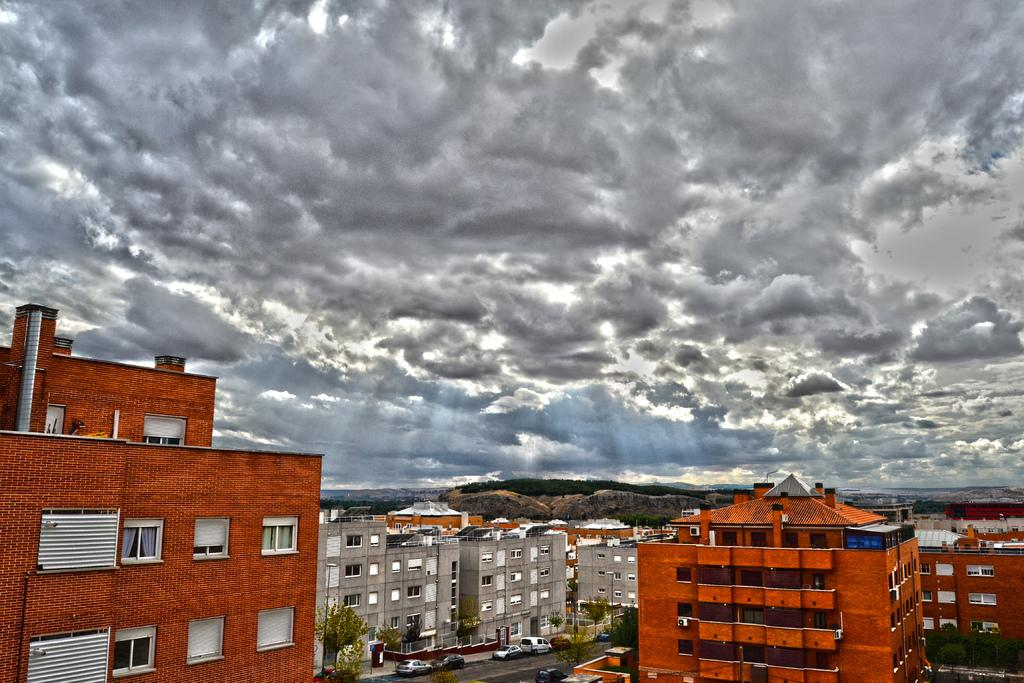What type of building can be seen on the left side of the image? There is a building in orange color on the left side of the image. What can be seen in the middle of the image? There are cars parked on the road in the middle of the image. What is the condition of the sky in the image? The sky is cloudy in the image. Can you tell me how many actors are visible in the image? There are no actors present in the image; it features a building, cars, and a cloudy sky. What type of pocket can be seen in the image? There is no pocket present in the image. 